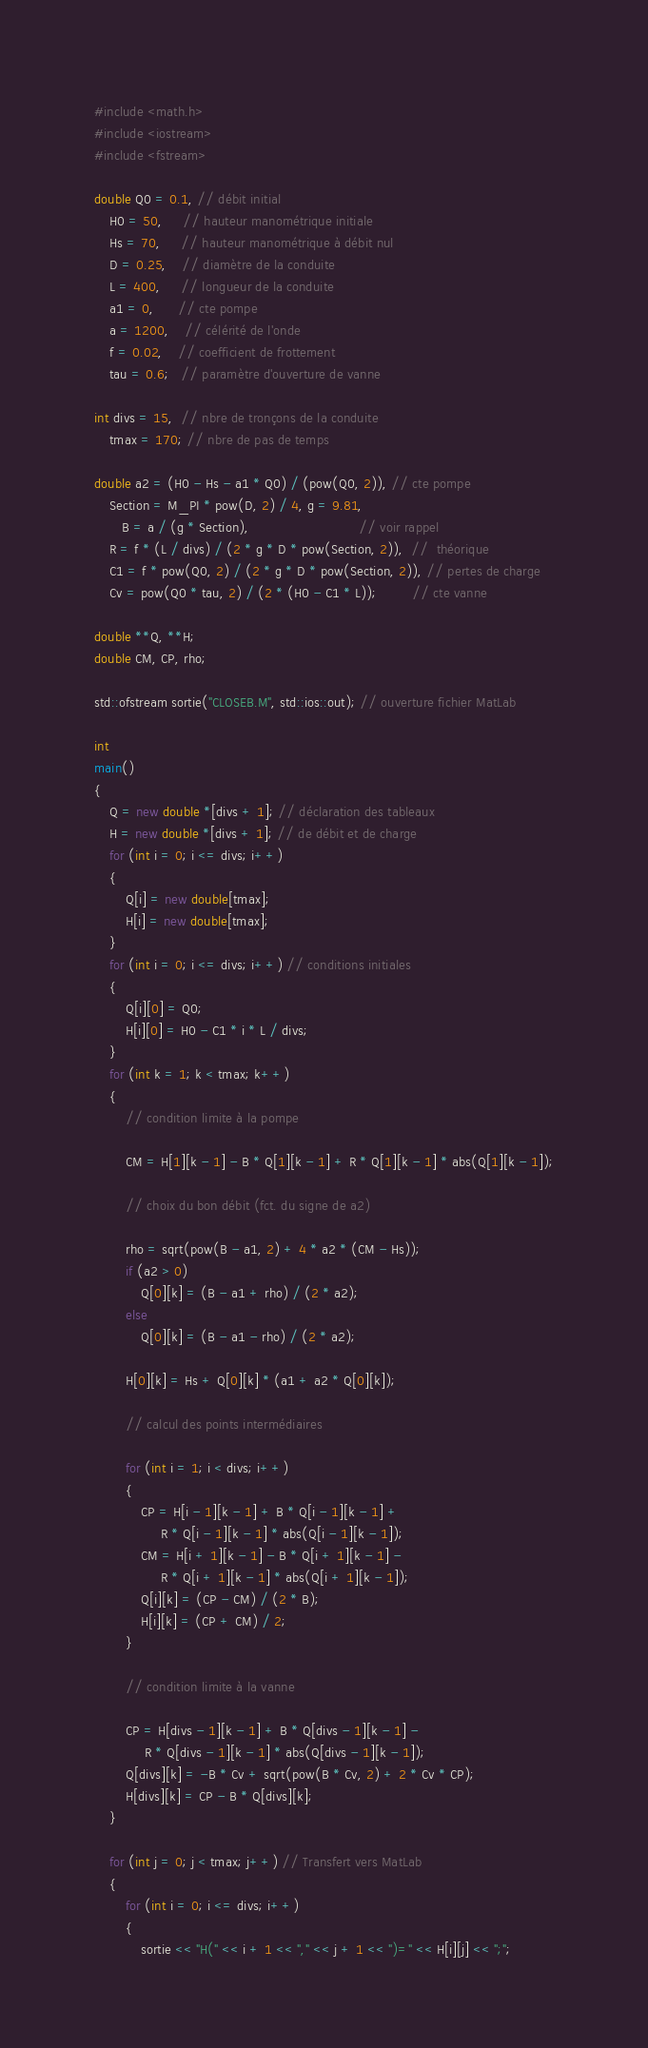Convert code to text. <code><loc_0><loc_0><loc_500><loc_500><_C++_>#include <math.h>
#include <iostream>
#include <fstream>

double Q0 = 0.1, // débit initial
    H0 = 50,     // hauteur manométrique initiale
    Hs = 70,     // hauteur manométrique à débit nul
    D = 0.25,    // diamètre de la conduite
    L = 400,     // longueur de la conduite
    a1 = 0,      // cte pompe
    a = 1200,    // célérité de l'onde
    f = 0.02,    // coefficient de frottement
    tau = 0.6;   // paramètre d'ouverture de vanne

int divs = 15,  // nbre de tronçons de la conduite
    tmax = 170; // nbre de pas de temps

double a2 = (H0 - Hs - a1 * Q0) / (pow(Q0, 2)), // cte pompe
    Section = M_PI * pow(D, 2) / 4, g = 9.81,
       B = a / (g * Section),                            // voir rappel
    R = f * (L / divs) / (2 * g * D * pow(Section, 2)),  //  théorique
    C1 = f * pow(Q0, 2) / (2 * g * D * pow(Section, 2)), // pertes de charge
    Cv = pow(Q0 * tau, 2) / (2 * (H0 - C1 * L));         // cte vanne

double **Q, **H;
double CM, CP, rho;

std::ofstream sortie("CLOSEB.M", std::ios::out); // ouverture fichier MatLab

int
main()
{
    Q = new double *[divs + 1]; // déclaration des tableaux
    H = new double *[divs + 1]; // de débit et de charge
    for (int i = 0; i <= divs; i++)
    {
        Q[i] = new double[tmax];
        H[i] = new double[tmax];
    }
    for (int i = 0; i <= divs; i++) // conditions initiales
    {
        Q[i][0] = Q0;
        H[i][0] = H0 - C1 * i * L / divs;
    }
    for (int k = 1; k < tmax; k++)
    {
        // condition limite à la pompe

        CM = H[1][k - 1] - B * Q[1][k - 1] + R * Q[1][k - 1] * abs(Q[1][k - 1]);

        // choix du bon débit (fct. du signe de a2)

        rho = sqrt(pow(B - a1, 2) + 4 * a2 * (CM - Hs));
        if (a2 > 0)
            Q[0][k] = (B - a1 + rho) / (2 * a2);
        else
            Q[0][k] = (B - a1 - rho) / (2 * a2);

        H[0][k] = Hs + Q[0][k] * (a1 + a2 * Q[0][k]);

        // calcul des points intermédiaires

        for (int i = 1; i < divs; i++)
        {
            CP = H[i - 1][k - 1] + B * Q[i - 1][k - 1] +
                 R * Q[i - 1][k - 1] * abs(Q[i - 1][k - 1]);
            CM = H[i + 1][k - 1] - B * Q[i + 1][k - 1] -
                 R * Q[i + 1][k - 1] * abs(Q[i + 1][k - 1]);
            Q[i][k] = (CP - CM) / (2 * B);
            H[i][k] = (CP + CM) / 2;
        }

        // condition limite à la vanne

        CP = H[divs - 1][k - 1] + B * Q[divs - 1][k - 1] -
             R * Q[divs - 1][k - 1] * abs(Q[divs - 1][k - 1]);
        Q[divs][k] = -B * Cv + sqrt(pow(B * Cv, 2) + 2 * Cv * CP);
        H[divs][k] = CP - B * Q[divs][k];
    }

    for (int j = 0; j < tmax; j++) // Transfert vers MatLab
    {
        for (int i = 0; i <= divs; i++)
        {
            sortie << "H(" << i + 1 << "," << j + 1 << ")=" << H[i][j] << ";";</code> 